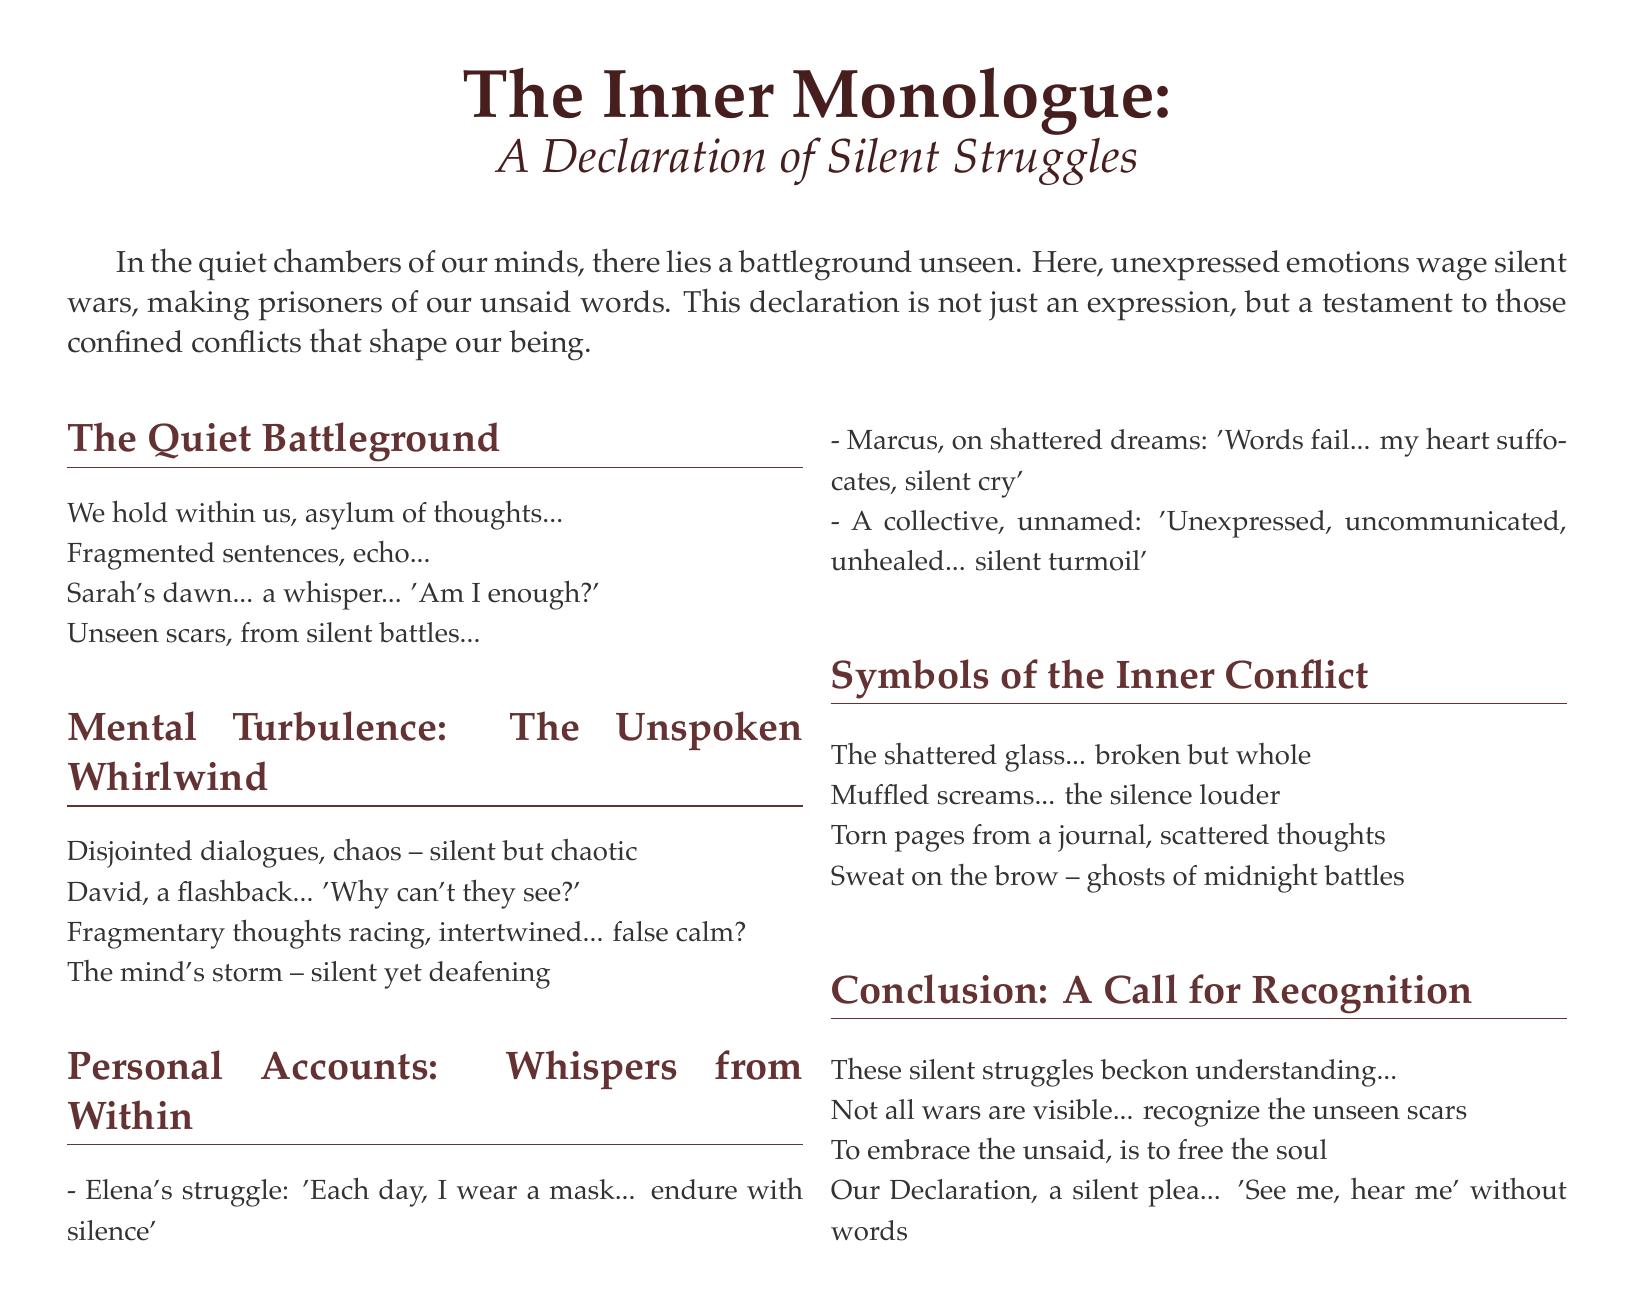What is the title of the declaration? The title is prominently displayed as the main heading in the document.
Answer: The Inner Monologue Who is mentioned in connection with the phrase 'Am I enough?' This phrase is attributed to an individual in the context of a silent struggle.
Answer: Sarah What is said about Elena's daily experience? The document depicts Elena's struggle with her emotions and how she copes with her reality.
Answer: 'Each day, I wear a mask... endure with silence' What symbolizes the silent battles described in the declaration? The declaration uses various symbols to represent inner conflicts experienced by individuals.
Answer: The shattered glass What is the primary call to action in the conclusion? The conclusion culminates in a plea for awareness regarding silent struggles.
Answer: 'See me, hear me' without words 